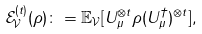Convert formula to latex. <formula><loc_0><loc_0><loc_500><loc_500>\mathcal { E } _ { \mathcal { V } } ^ { ( t ) } ( \rho ) & \colon = \mathbb { E } _ { \mathcal { V } } [ U _ { \mu } ^ { \otimes t } \rho ( U _ { \mu } ^ { \dagger } ) ^ { \otimes t } ] ,</formula> 